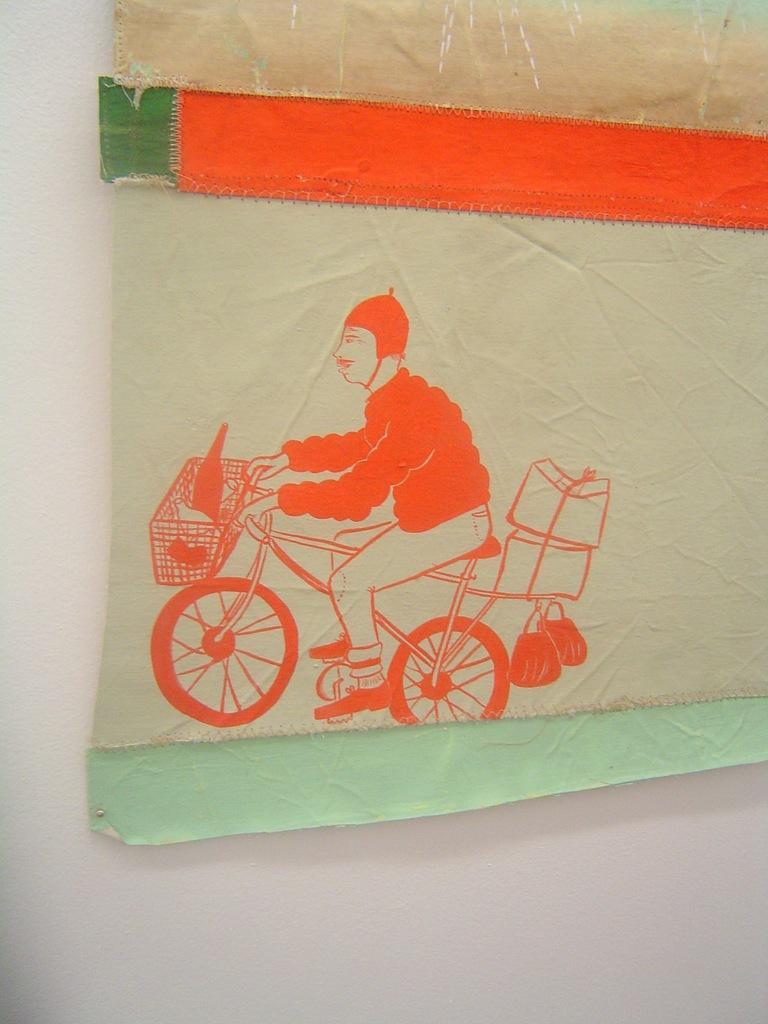Can you describe this image briefly? There is a poster on the wall and on it there is a figure of a person riding a bicycle. 